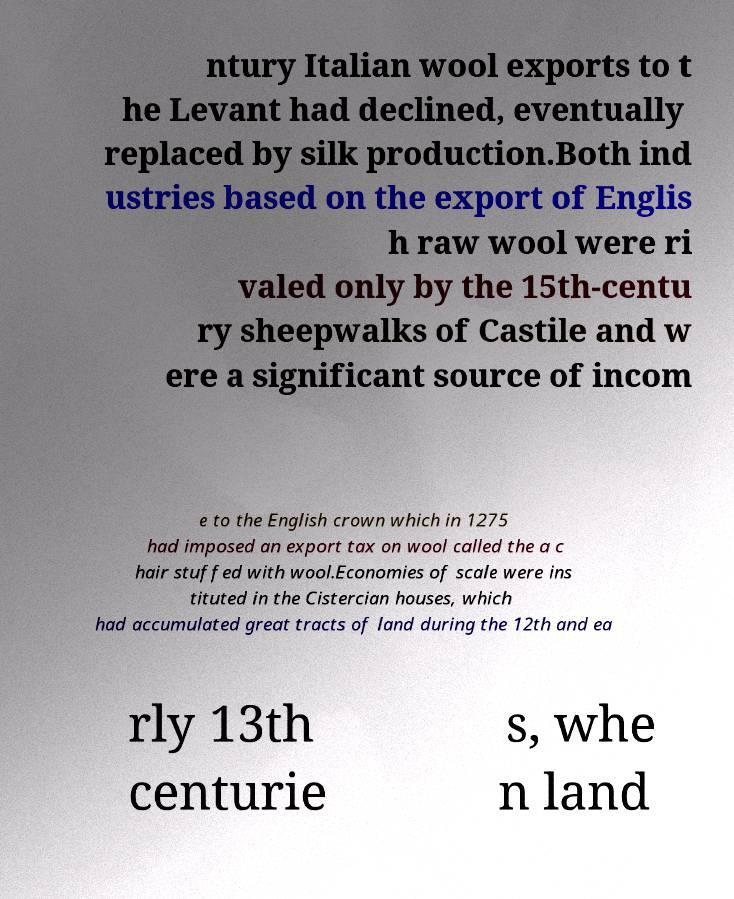What messages or text are displayed in this image? I need them in a readable, typed format. ntury Italian wool exports to t he Levant had declined, eventually replaced by silk production.Both ind ustries based on the export of Englis h raw wool were ri valed only by the 15th-centu ry sheepwalks of Castile and w ere a significant source of incom e to the English crown which in 1275 had imposed an export tax on wool called the a c hair stuffed with wool.Economies of scale were ins tituted in the Cistercian houses, which had accumulated great tracts of land during the 12th and ea rly 13th centurie s, whe n land 